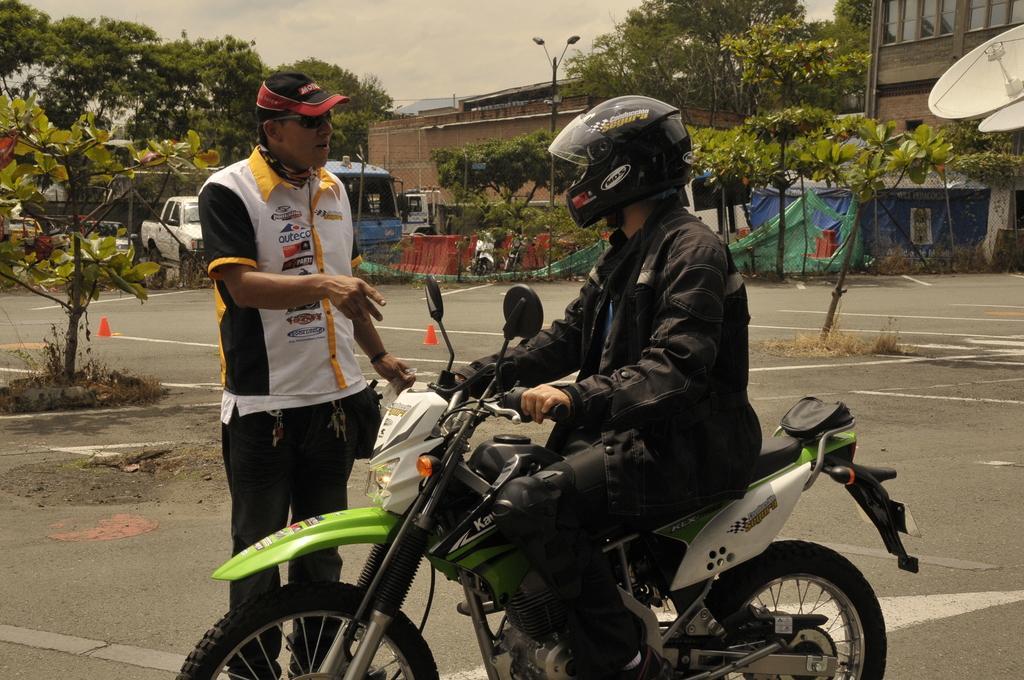In one or two sentences, can you explain what this image depicts? This person sitting and holding bike and wear helmet,this person standing and wear cap,glasses. On the background we can see buildings,lights,pole,trees,sky,vehicles on the road. 